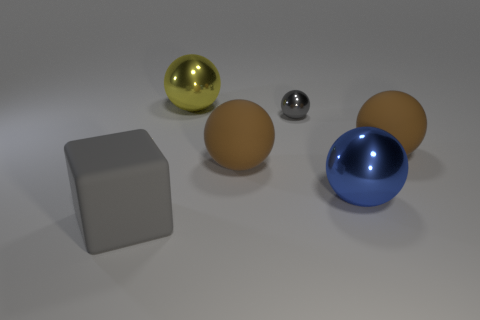Subtract all brown balls. How many were subtracted if there are1brown balls left? 1 Subtract all blue spheres. How many spheres are left? 4 Subtract all blue balls. How many balls are left? 4 Add 1 brown rubber spheres. How many objects exist? 7 Subtract all red spheres. Subtract all cyan cubes. How many spheres are left? 5 Subtract all balls. How many objects are left? 1 Subtract 0 purple spheres. How many objects are left? 6 Subtract all big brown things. Subtract all large gray rubber blocks. How many objects are left? 3 Add 4 metal balls. How many metal balls are left? 7 Add 1 small red shiny spheres. How many small red shiny spheres exist? 1 